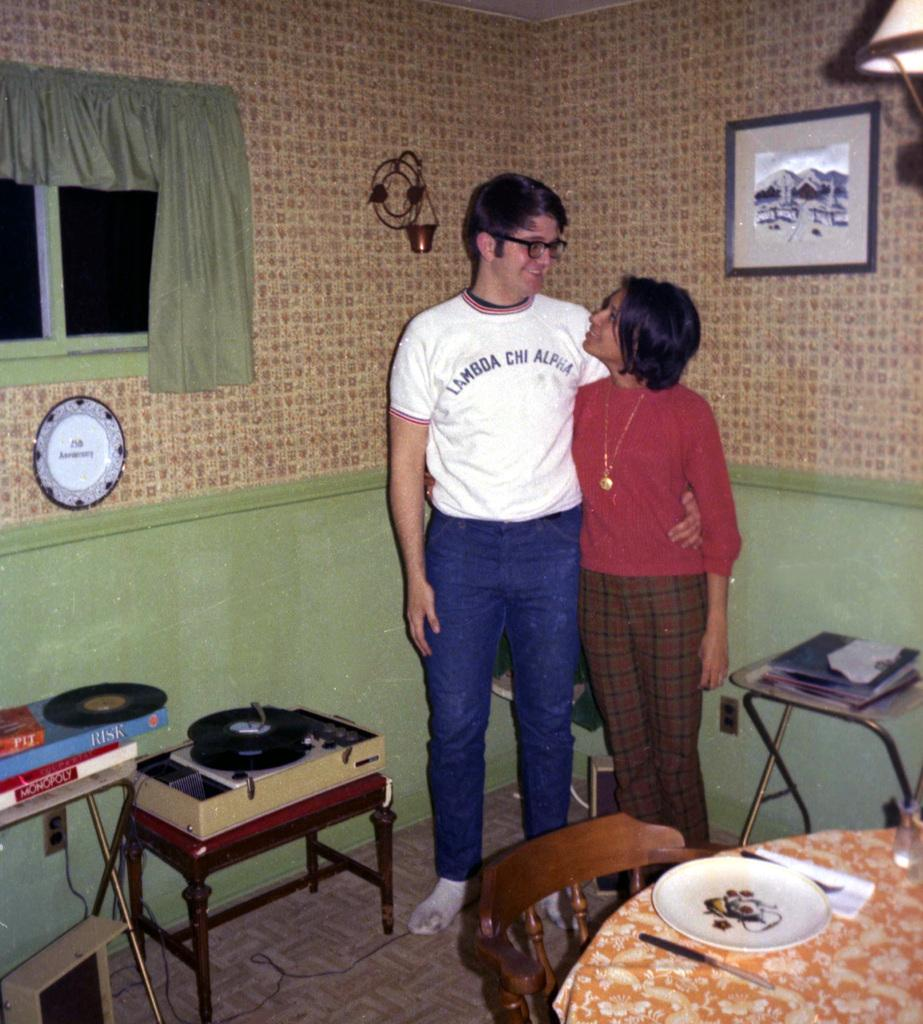Provide a one-sentence caption for the provided image. A man wearing a Lambda Chi Alpha has his arm around a woman. 